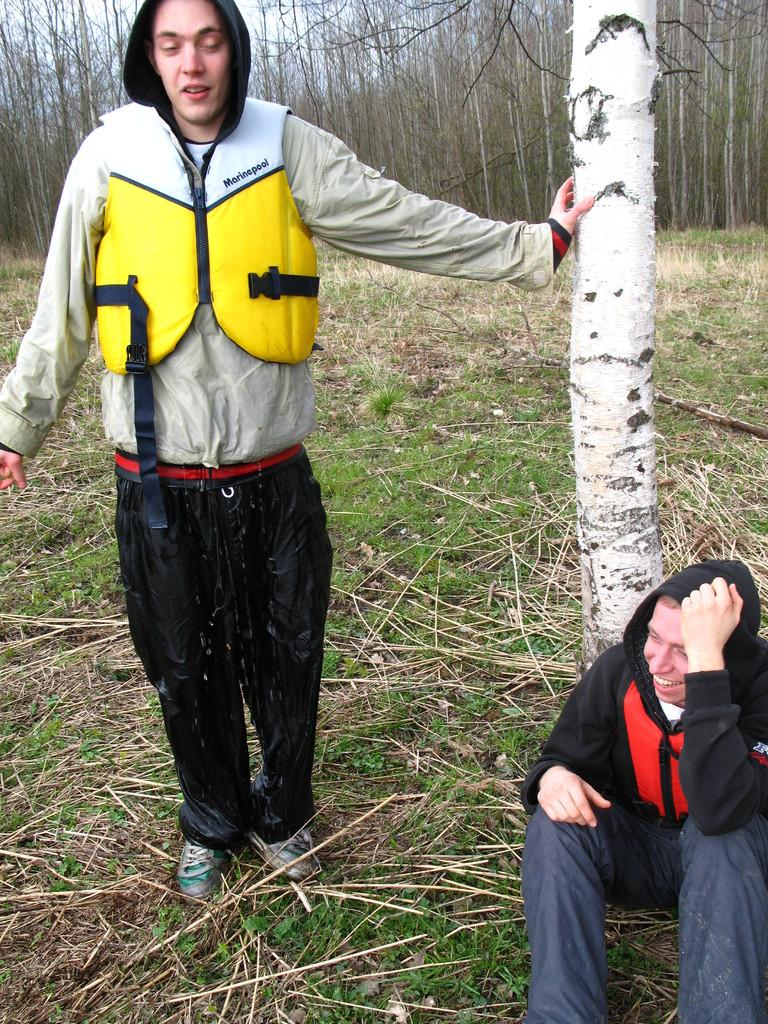What is the position of the person in the image? There is a person sitting in the image. What is the other person in the image doing? There is another person standing in the image. What type of vegetation can be seen in the image? There is grass visible in the image. What can be seen in the background of the image? There are trees in the background of the image. Is the person sitting in the image being punished for walking through the quicksand? There is no quicksand or any indication of punishment in the image. The person is simply sitting, and the other person is standing. 